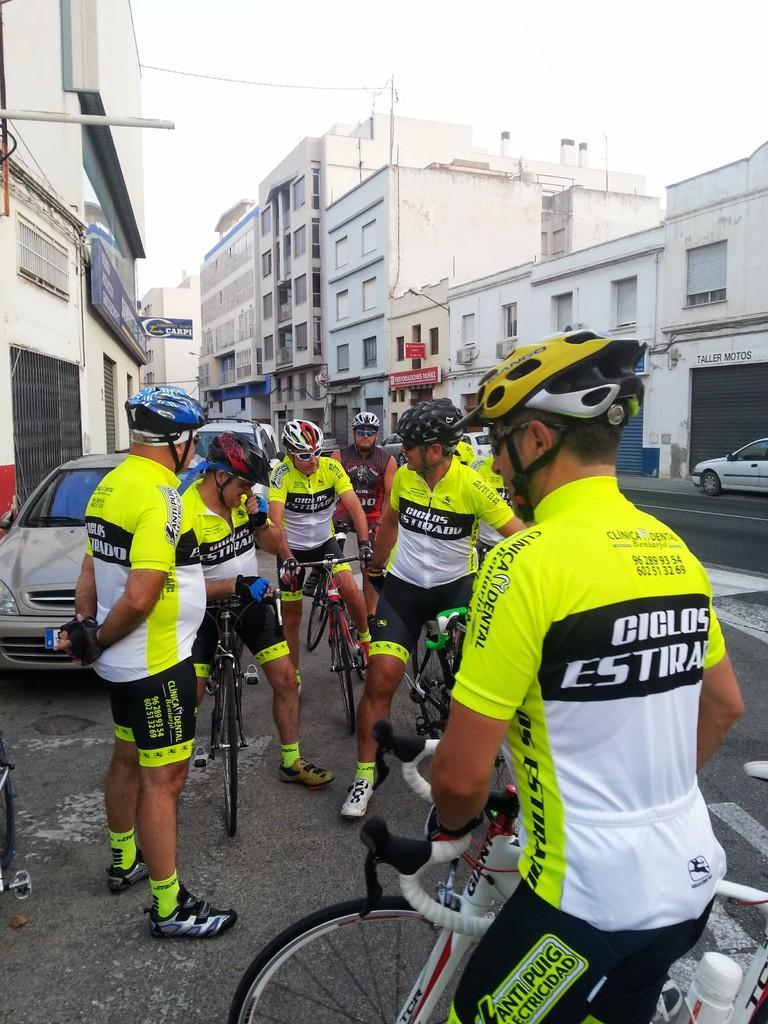Describe this image in one or two sentences. In this picture we can see five cycle riders wearing yellow and white color t-shirt sitting on the bicycle and discussing something seen in the image. Behind we can see silver car is parked. In the background we can see some white buildings and a road. 